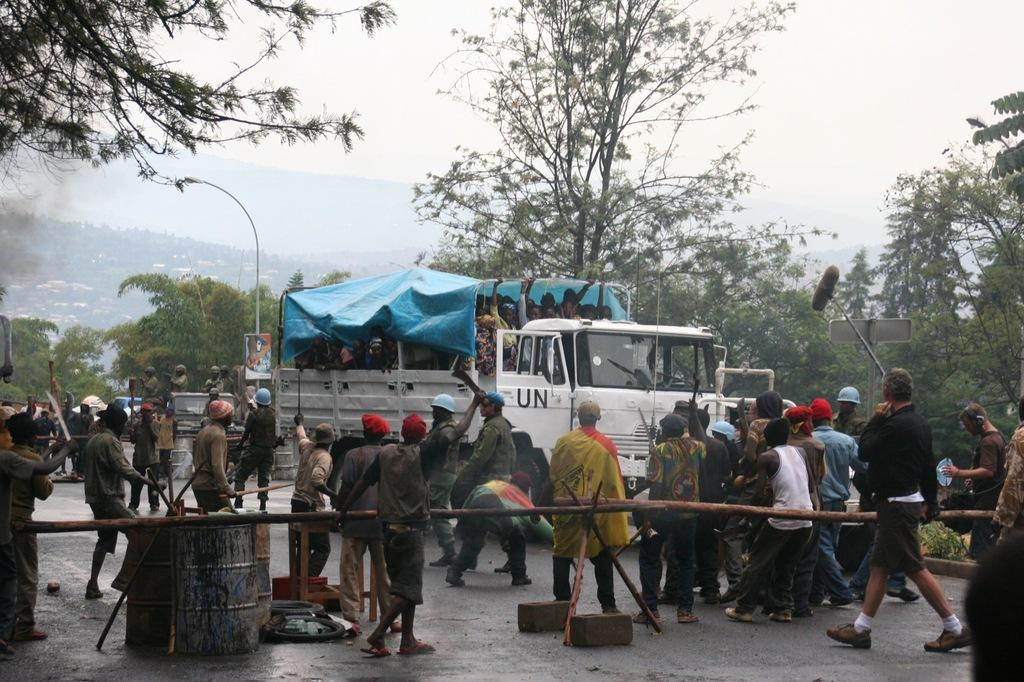How many people are in the group visible in the image? There is a group of people in the image, but the exact number cannot be determined from the provided facts. What type of vehicle is in the image? There is a truck in the image. Where are the truck and the group of people located in the image? The truck and the group of people are at the bottom of the image. What can be seen in the background of the image? There are trees in the background of the image. What is visible at the top of the image? The sky is visible at the top of the image. What is the reaction of the people to the sudden shake in the image? There is no mention of a shake or any reaction by the people in the image. 